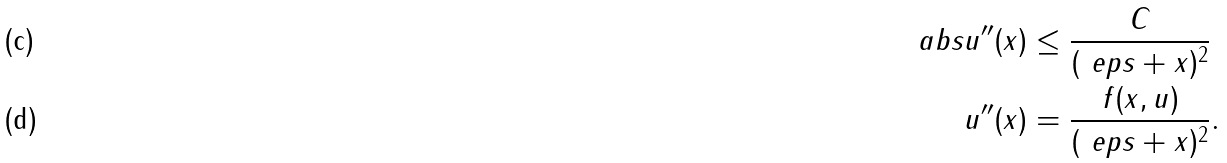<formula> <loc_0><loc_0><loc_500><loc_500>\ a b s { u ^ { \prime \prime } ( x ) } & \leq \frac { C } { ( \ e p s + x ) ^ { 2 } } \\ u ^ { \prime \prime } ( x ) & = \frac { f ( x , u ) } { ( \ e p s + x ) ^ { 2 } } .</formula> 